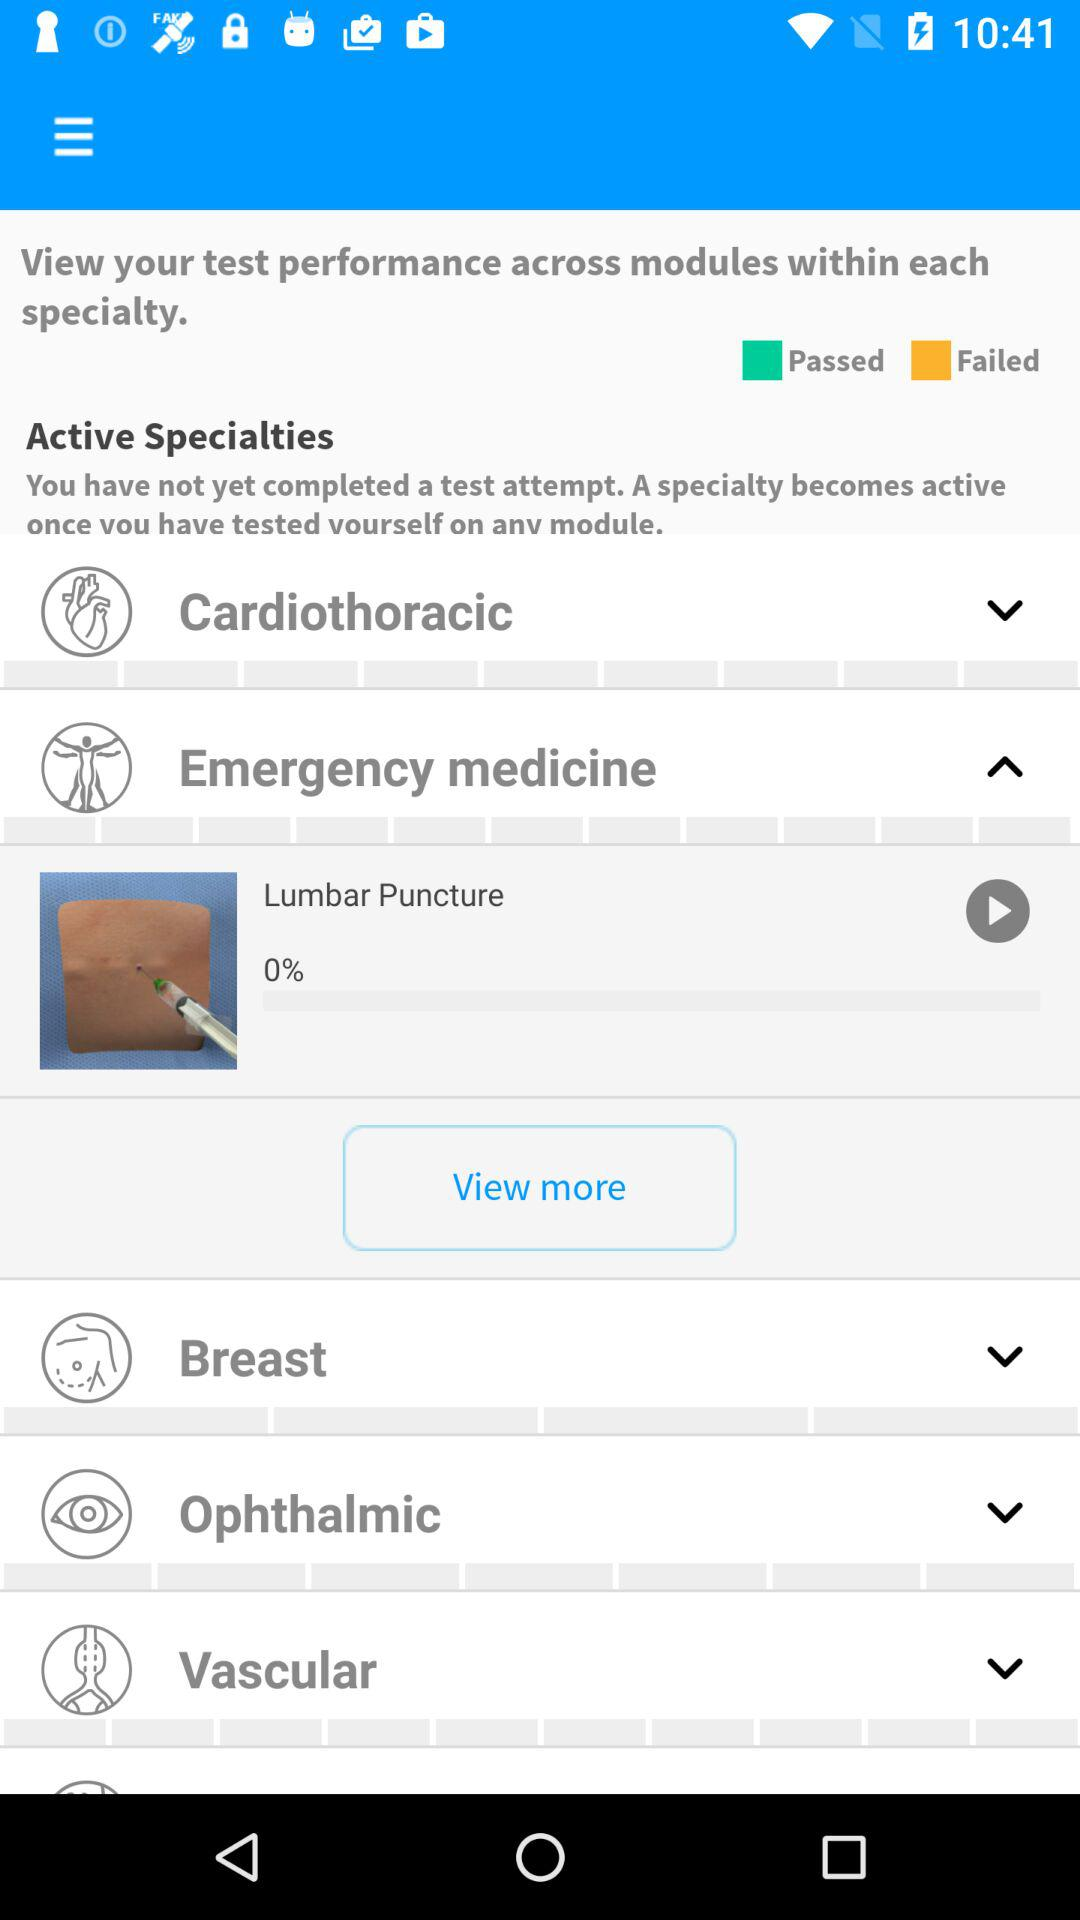What is the percentage of videos watched of "Lumbar Puncture"? The video was viewed 0%. 